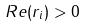Convert formula to latex. <formula><loc_0><loc_0><loc_500><loc_500>R e ( r _ { i } ) > 0</formula> 